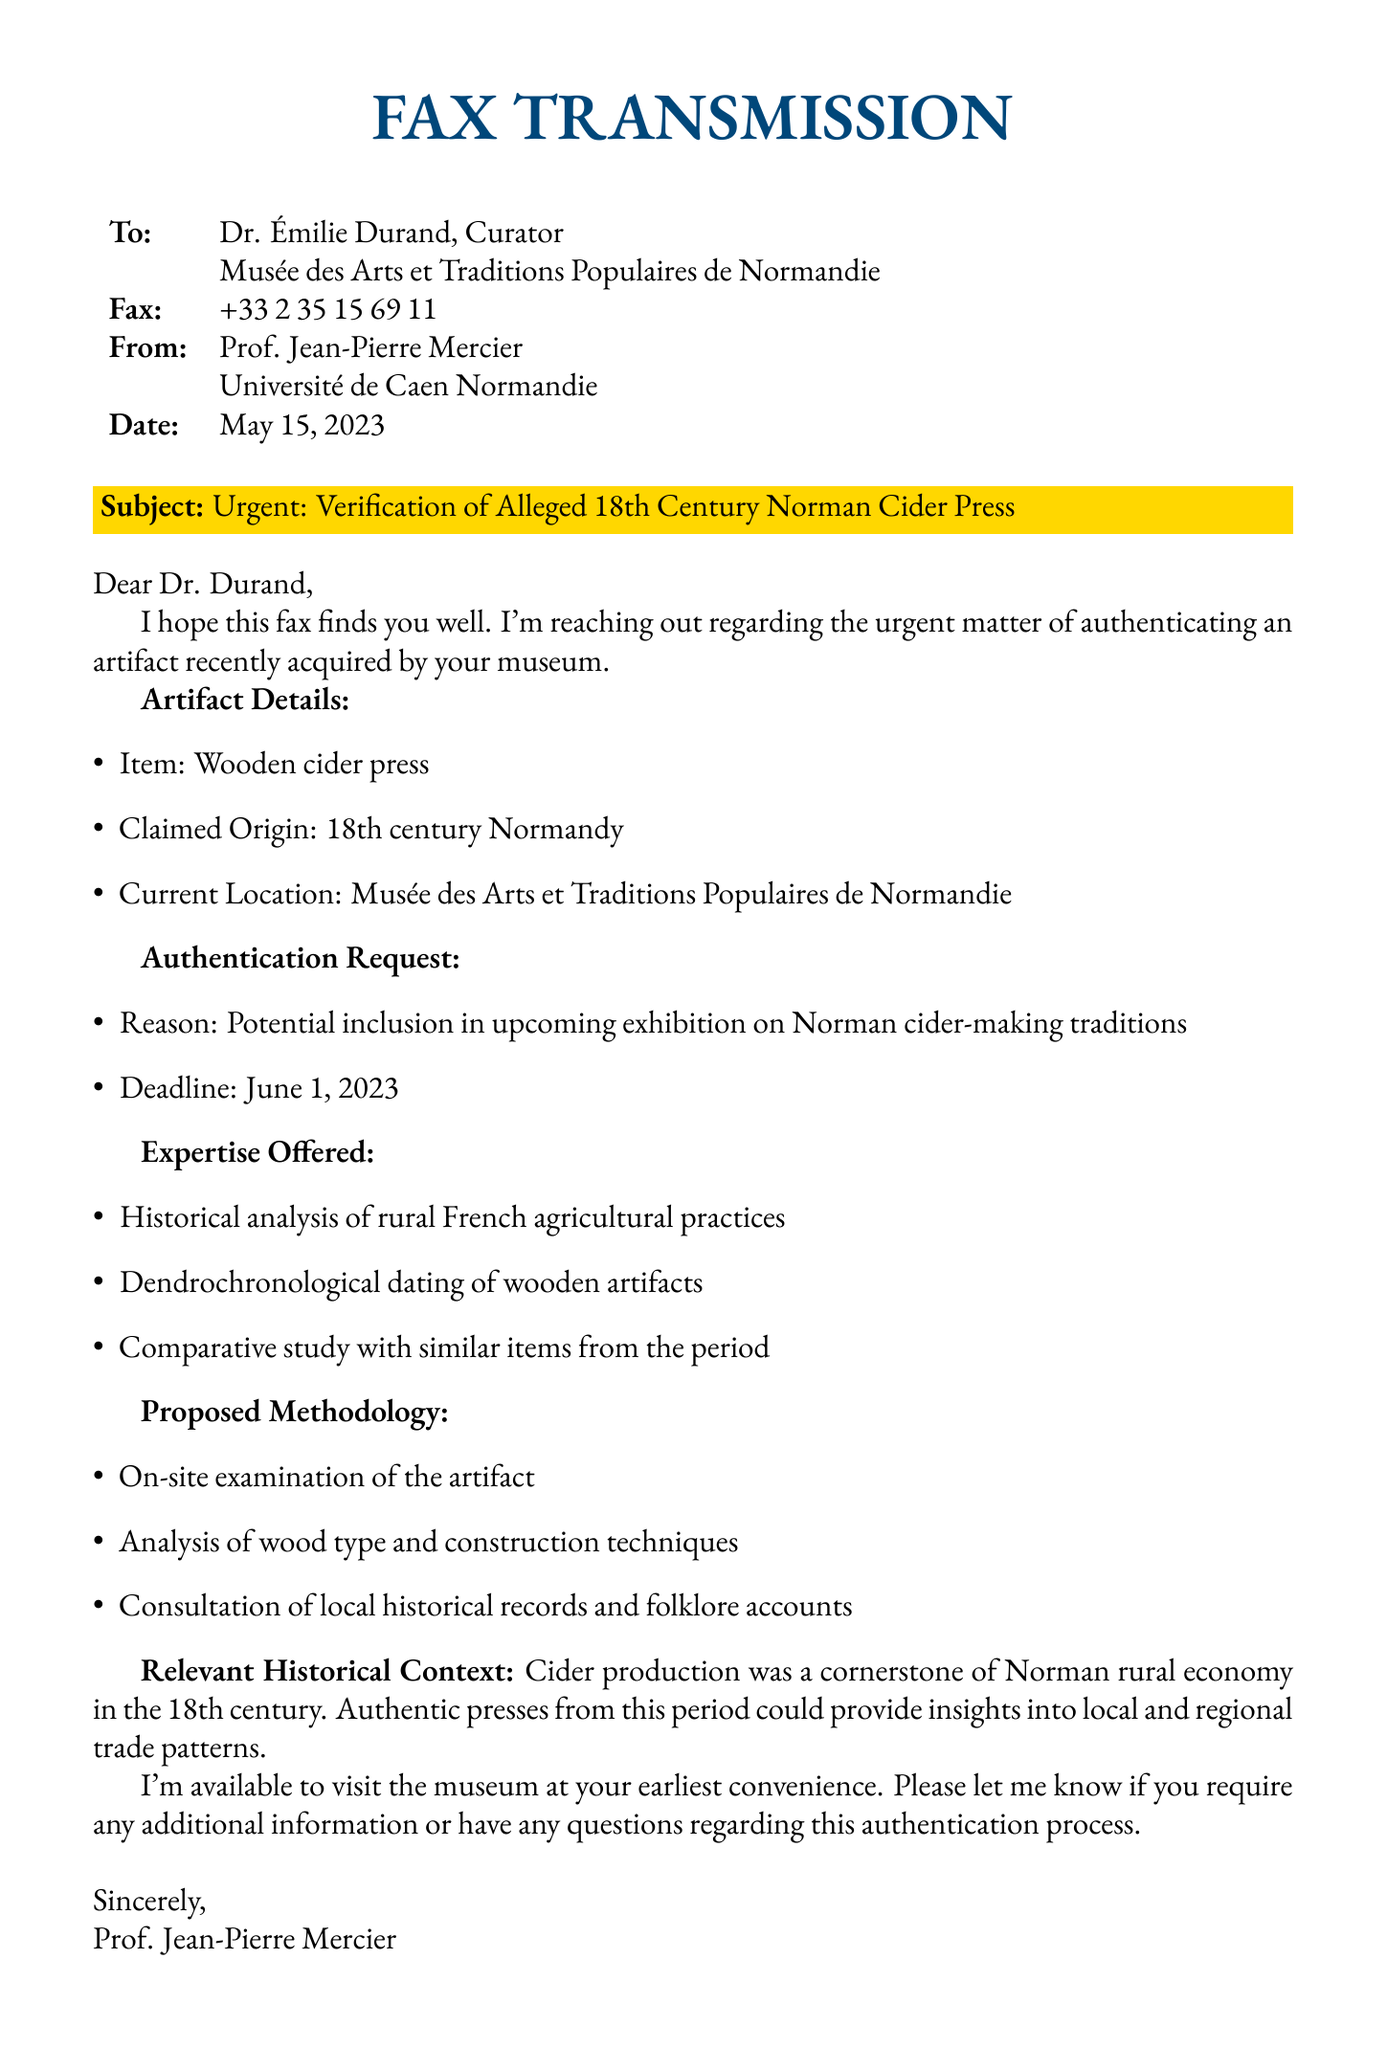What is the subject of the fax? The subject of the fax is stated in the highlighted section at the beginning of the document.
Answer: Urgent: Verification of Alleged 18th Century Norman Cider Press Who is the sender of the fax? The sender's name and affiliation are listed at the top of the document.
Answer: Prof. Jean-Pierre Mercier What is the claimed origin of the artifact? The claimed origin of the artifact is detailed in the artifact section of the fax.
Answer: 18th century Normandy What date is the fax sent? The date is specified near the top just below the sender and recipient information.
Answer: May 15, 2023 What is the deadline for the authentication request? The deadline is mentioned explicitly in the authentication request section.
Answer: June 1, 2023 What expertise does Prof. Mercier offer? The expertise offered is listed in a bulleted format in the fax.
Answer: Historical analysis of rural French agricultural practices What type of artifact is being authenticated? The type of artifact is clearly identified in the artifact details section.
Answer: Wooden cider press What method is proposed for the authentication? The proposed methodology is outlined with a list of steps in the fax.
Answer: On-site examination of the artifact Why is this artifact important to the museum? The importance is explained in the context section of the document.
Answer: Insights into local and regional trade patterns 